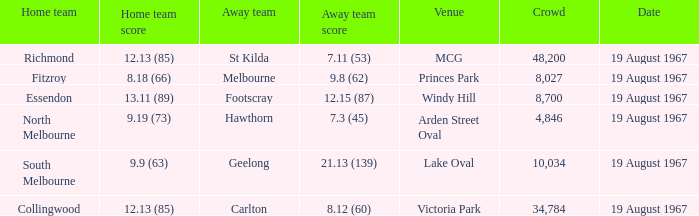Parse the full table. {'header': ['Home team', 'Home team score', 'Away team', 'Away team score', 'Venue', 'Crowd', 'Date'], 'rows': [['Richmond', '12.13 (85)', 'St Kilda', '7.11 (53)', 'MCG', '48,200', '19 August 1967'], ['Fitzroy', '8.18 (66)', 'Melbourne', '9.8 (62)', 'Princes Park', '8,027', '19 August 1967'], ['Essendon', '13.11 (89)', 'Footscray', '12.15 (87)', 'Windy Hill', '8,700', '19 August 1967'], ['North Melbourne', '9.19 (73)', 'Hawthorn', '7.3 (45)', 'Arden Street Oval', '4,846', '19 August 1967'], ['South Melbourne', '9.9 (63)', 'Geelong', '21.13 (139)', 'Lake Oval', '10,034', '19 August 1967'], ['Collingwood', '12.13 (85)', 'Carlton', '8.12 (60)', 'Victoria Park', '34,784', '19 August 1967']]} At lake oval venue, what score did the home team achieve? 9.9 (63). 